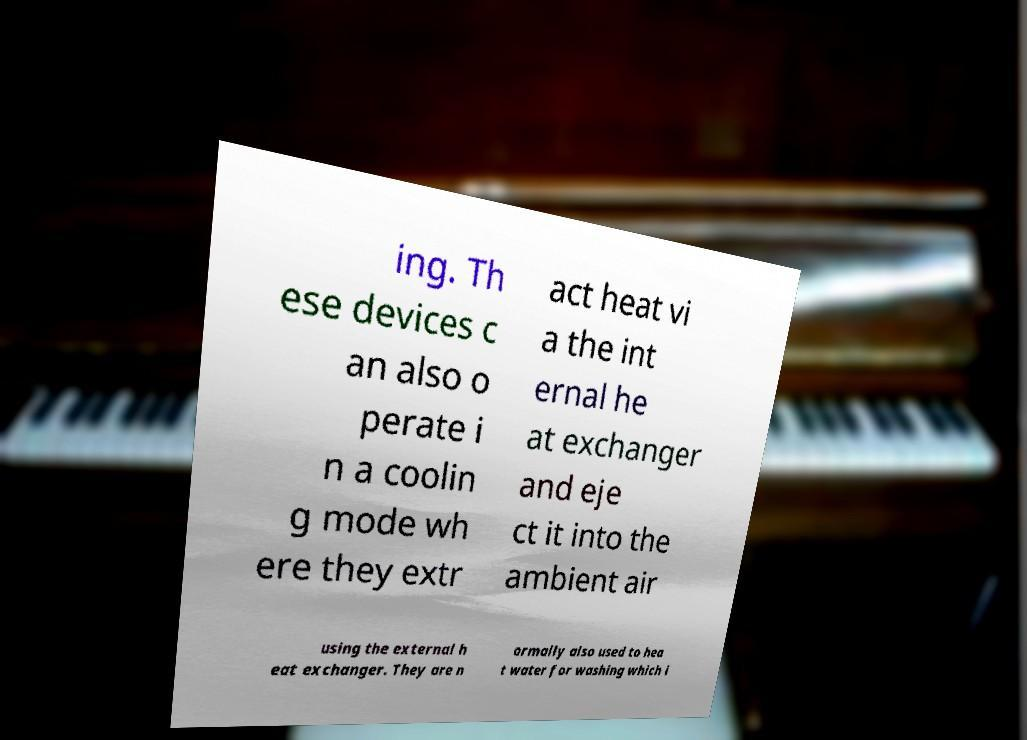I need the written content from this picture converted into text. Can you do that? ing. Th ese devices c an also o perate i n a coolin g mode wh ere they extr act heat vi a the int ernal he at exchanger and eje ct it into the ambient air using the external h eat exchanger. They are n ormally also used to hea t water for washing which i 